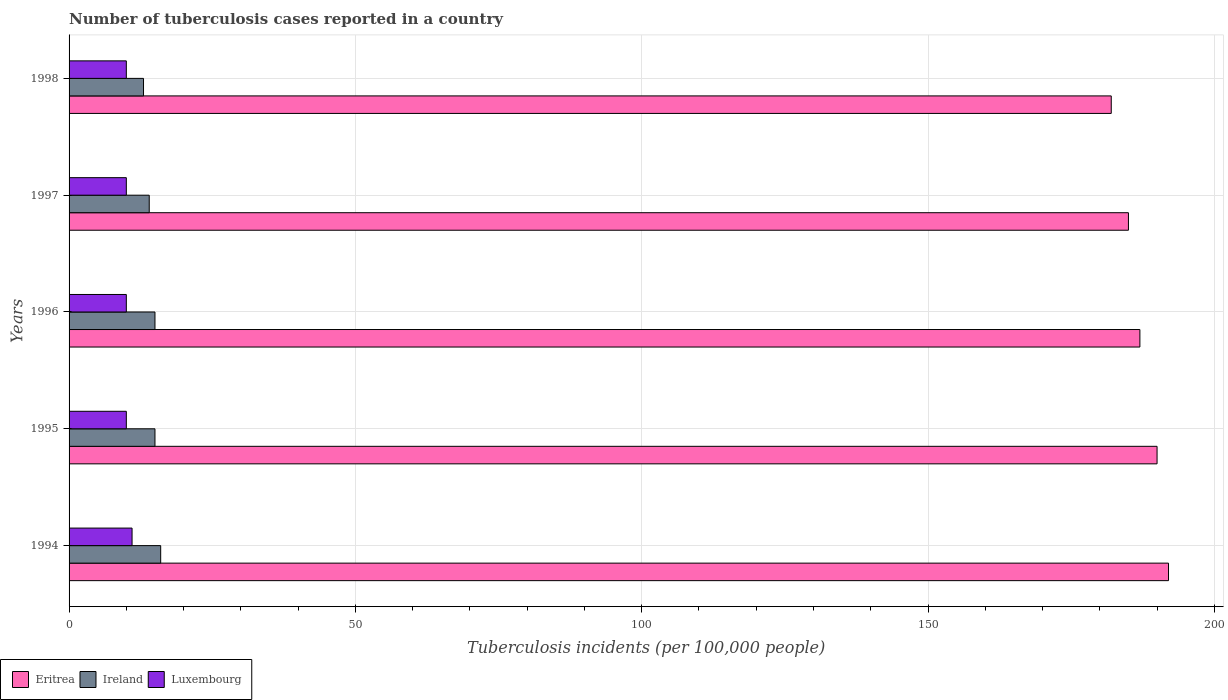How many groups of bars are there?
Make the answer very short. 5. How many bars are there on the 2nd tick from the bottom?
Provide a short and direct response. 3. Across all years, what is the maximum number of tuberculosis cases reported in in Ireland?
Your answer should be compact. 16. Across all years, what is the minimum number of tuberculosis cases reported in in Ireland?
Make the answer very short. 13. In which year was the number of tuberculosis cases reported in in Eritrea maximum?
Offer a terse response. 1994. In which year was the number of tuberculosis cases reported in in Eritrea minimum?
Your response must be concise. 1998. What is the difference between the number of tuberculosis cases reported in in Eritrea in 1995 and that in 1998?
Your response must be concise. 8. What is the difference between the number of tuberculosis cases reported in in Ireland in 1996 and the number of tuberculosis cases reported in in Luxembourg in 1995?
Keep it short and to the point. 5. In the year 1995, what is the difference between the number of tuberculosis cases reported in in Eritrea and number of tuberculosis cases reported in in Luxembourg?
Make the answer very short. 180. In how many years, is the number of tuberculosis cases reported in in Luxembourg greater than 140 ?
Your answer should be compact. 0. What is the ratio of the number of tuberculosis cases reported in in Ireland in 1994 to that in 1998?
Provide a short and direct response. 1.23. Is the difference between the number of tuberculosis cases reported in in Eritrea in 1994 and 1996 greater than the difference between the number of tuberculosis cases reported in in Luxembourg in 1994 and 1996?
Your answer should be very brief. Yes. What is the difference between the highest and the second highest number of tuberculosis cases reported in in Eritrea?
Give a very brief answer. 2. What is the difference between the highest and the lowest number of tuberculosis cases reported in in Eritrea?
Give a very brief answer. 10. What does the 3rd bar from the top in 1996 represents?
Your answer should be very brief. Eritrea. What does the 1st bar from the bottom in 1997 represents?
Give a very brief answer. Eritrea. Is it the case that in every year, the sum of the number of tuberculosis cases reported in in Eritrea and number of tuberculosis cases reported in in Luxembourg is greater than the number of tuberculosis cases reported in in Ireland?
Provide a succinct answer. Yes. How many bars are there?
Ensure brevity in your answer.  15. What is the difference between two consecutive major ticks on the X-axis?
Your answer should be compact. 50. Are the values on the major ticks of X-axis written in scientific E-notation?
Offer a terse response. No. Does the graph contain any zero values?
Offer a very short reply. No. How many legend labels are there?
Provide a succinct answer. 3. How are the legend labels stacked?
Provide a succinct answer. Horizontal. What is the title of the graph?
Your answer should be compact. Number of tuberculosis cases reported in a country. What is the label or title of the X-axis?
Give a very brief answer. Tuberculosis incidents (per 100,0 people). What is the label or title of the Y-axis?
Your response must be concise. Years. What is the Tuberculosis incidents (per 100,000 people) of Eritrea in 1994?
Provide a succinct answer. 192. What is the Tuberculosis incidents (per 100,000 people) of Luxembourg in 1994?
Ensure brevity in your answer.  11. What is the Tuberculosis incidents (per 100,000 people) in Eritrea in 1995?
Your response must be concise. 190. What is the Tuberculosis incidents (per 100,000 people) of Ireland in 1995?
Your answer should be compact. 15. What is the Tuberculosis incidents (per 100,000 people) of Eritrea in 1996?
Provide a short and direct response. 187. What is the Tuberculosis incidents (per 100,000 people) in Luxembourg in 1996?
Offer a terse response. 10. What is the Tuberculosis incidents (per 100,000 people) in Eritrea in 1997?
Offer a terse response. 185. What is the Tuberculosis incidents (per 100,000 people) of Ireland in 1997?
Provide a short and direct response. 14. What is the Tuberculosis incidents (per 100,000 people) in Eritrea in 1998?
Provide a succinct answer. 182. What is the Tuberculosis incidents (per 100,000 people) of Luxembourg in 1998?
Keep it short and to the point. 10. Across all years, what is the maximum Tuberculosis incidents (per 100,000 people) in Eritrea?
Make the answer very short. 192. Across all years, what is the maximum Tuberculosis incidents (per 100,000 people) in Luxembourg?
Make the answer very short. 11. Across all years, what is the minimum Tuberculosis incidents (per 100,000 people) in Eritrea?
Keep it short and to the point. 182. Across all years, what is the minimum Tuberculosis incidents (per 100,000 people) of Ireland?
Your response must be concise. 13. Across all years, what is the minimum Tuberculosis incidents (per 100,000 people) in Luxembourg?
Your response must be concise. 10. What is the total Tuberculosis incidents (per 100,000 people) in Eritrea in the graph?
Your answer should be compact. 936. What is the total Tuberculosis incidents (per 100,000 people) of Ireland in the graph?
Offer a terse response. 73. What is the difference between the Tuberculosis incidents (per 100,000 people) in Eritrea in 1994 and that in 1995?
Your answer should be compact. 2. What is the difference between the Tuberculosis incidents (per 100,000 people) in Luxembourg in 1994 and that in 1995?
Offer a terse response. 1. What is the difference between the Tuberculosis incidents (per 100,000 people) in Eritrea in 1994 and that in 1996?
Provide a short and direct response. 5. What is the difference between the Tuberculosis incidents (per 100,000 people) in Ireland in 1994 and that in 1996?
Provide a short and direct response. 1. What is the difference between the Tuberculosis incidents (per 100,000 people) of Eritrea in 1994 and that in 1997?
Ensure brevity in your answer.  7. What is the difference between the Tuberculosis incidents (per 100,000 people) of Luxembourg in 1994 and that in 1997?
Give a very brief answer. 1. What is the difference between the Tuberculosis incidents (per 100,000 people) of Eritrea in 1994 and that in 1998?
Your answer should be compact. 10. What is the difference between the Tuberculosis incidents (per 100,000 people) in Luxembourg in 1994 and that in 1998?
Your answer should be compact. 1. What is the difference between the Tuberculosis incidents (per 100,000 people) of Ireland in 1995 and that in 1996?
Offer a terse response. 0. What is the difference between the Tuberculosis incidents (per 100,000 people) of Luxembourg in 1995 and that in 1996?
Provide a succinct answer. 0. What is the difference between the Tuberculosis incidents (per 100,000 people) of Eritrea in 1995 and that in 1997?
Provide a short and direct response. 5. What is the difference between the Tuberculosis incidents (per 100,000 people) of Ireland in 1995 and that in 1997?
Your response must be concise. 1. What is the difference between the Tuberculosis incidents (per 100,000 people) of Luxembourg in 1995 and that in 1997?
Your response must be concise. 0. What is the difference between the Tuberculosis incidents (per 100,000 people) in Eritrea in 1996 and that in 1997?
Give a very brief answer. 2. What is the difference between the Tuberculosis incidents (per 100,000 people) of Ireland in 1996 and that in 1997?
Provide a succinct answer. 1. What is the difference between the Tuberculosis incidents (per 100,000 people) of Luxembourg in 1996 and that in 1997?
Your answer should be very brief. 0. What is the difference between the Tuberculosis incidents (per 100,000 people) of Ireland in 1996 and that in 1998?
Give a very brief answer. 2. What is the difference between the Tuberculosis incidents (per 100,000 people) in Luxembourg in 1996 and that in 1998?
Keep it short and to the point. 0. What is the difference between the Tuberculosis incidents (per 100,000 people) in Eritrea in 1997 and that in 1998?
Provide a short and direct response. 3. What is the difference between the Tuberculosis incidents (per 100,000 people) of Ireland in 1997 and that in 1998?
Your answer should be compact. 1. What is the difference between the Tuberculosis incidents (per 100,000 people) of Luxembourg in 1997 and that in 1998?
Provide a succinct answer. 0. What is the difference between the Tuberculosis incidents (per 100,000 people) of Eritrea in 1994 and the Tuberculosis incidents (per 100,000 people) of Ireland in 1995?
Your answer should be very brief. 177. What is the difference between the Tuberculosis incidents (per 100,000 people) of Eritrea in 1994 and the Tuberculosis incidents (per 100,000 people) of Luxembourg in 1995?
Ensure brevity in your answer.  182. What is the difference between the Tuberculosis incidents (per 100,000 people) in Eritrea in 1994 and the Tuberculosis incidents (per 100,000 people) in Ireland in 1996?
Offer a terse response. 177. What is the difference between the Tuberculosis incidents (per 100,000 people) in Eritrea in 1994 and the Tuberculosis incidents (per 100,000 people) in Luxembourg in 1996?
Ensure brevity in your answer.  182. What is the difference between the Tuberculosis incidents (per 100,000 people) in Eritrea in 1994 and the Tuberculosis incidents (per 100,000 people) in Ireland in 1997?
Your answer should be very brief. 178. What is the difference between the Tuberculosis incidents (per 100,000 people) of Eritrea in 1994 and the Tuberculosis incidents (per 100,000 people) of Luxembourg in 1997?
Offer a very short reply. 182. What is the difference between the Tuberculosis incidents (per 100,000 people) of Ireland in 1994 and the Tuberculosis incidents (per 100,000 people) of Luxembourg in 1997?
Your answer should be very brief. 6. What is the difference between the Tuberculosis incidents (per 100,000 people) in Eritrea in 1994 and the Tuberculosis incidents (per 100,000 people) in Ireland in 1998?
Give a very brief answer. 179. What is the difference between the Tuberculosis incidents (per 100,000 people) of Eritrea in 1994 and the Tuberculosis incidents (per 100,000 people) of Luxembourg in 1998?
Provide a succinct answer. 182. What is the difference between the Tuberculosis incidents (per 100,000 people) in Ireland in 1994 and the Tuberculosis incidents (per 100,000 people) in Luxembourg in 1998?
Provide a short and direct response. 6. What is the difference between the Tuberculosis incidents (per 100,000 people) of Eritrea in 1995 and the Tuberculosis incidents (per 100,000 people) of Ireland in 1996?
Your answer should be compact. 175. What is the difference between the Tuberculosis incidents (per 100,000 people) of Eritrea in 1995 and the Tuberculosis incidents (per 100,000 people) of Luxembourg in 1996?
Offer a terse response. 180. What is the difference between the Tuberculosis incidents (per 100,000 people) of Ireland in 1995 and the Tuberculosis incidents (per 100,000 people) of Luxembourg in 1996?
Your response must be concise. 5. What is the difference between the Tuberculosis incidents (per 100,000 people) of Eritrea in 1995 and the Tuberculosis incidents (per 100,000 people) of Ireland in 1997?
Offer a very short reply. 176. What is the difference between the Tuberculosis incidents (per 100,000 people) in Eritrea in 1995 and the Tuberculosis incidents (per 100,000 people) in Luxembourg in 1997?
Offer a very short reply. 180. What is the difference between the Tuberculosis incidents (per 100,000 people) in Ireland in 1995 and the Tuberculosis incidents (per 100,000 people) in Luxembourg in 1997?
Provide a short and direct response. 5. What is the difference between the Tuberculosis incidents (per 100,000 people) of Eritrea in 1995 and the Tuberculosis incidents (per 100,000 people) of Ireland in 1998?
Provide a succinct answer. 177. What is the difference between the Tuberculosis incidents (per 100,000 people) in Eritrea in 1995 and the Tuberculosis incidents (per 100,000 people) in Luxembourg in 1998?
Your answer should be very brief. 180. What is the difference between the Tuberculosis incidents (per 100,000 people) of Eritrea in 1996 and the Tuberculosis incidents (per 100,000 people) of Ireland in 1997?
Offer a terse response. 173. What is the difference between the Tuberculosis incidents (per 100,000 people) in Eritrea in 1996 and the Tuberculosis incidents (per 100,000 people) in Luxembourg in 1997?
Your answer should be compact. 177. What is the difference between the Tuberculosis incidents (per 100,000 people) in Eritrea in 1996 and the Tuberculosis incidents (per 100,000 people) in Ireland in 1998?
Your answer should be very brief. 174. What is the difference between the Tuberculosis incidents (per 100,000 people) in Eritrea in 1996 and the Tuberculosis incidents (per 100,000 people) in Luxembourg in 1998?
Your response must be concise. 177. What is the difference between the Tuberculosis incidents (per 100,000 people) in Ireland in 1996 and the Tuberculosis incidents (per 100,000 people) in Luxembourg in 1998?
Make the answer very short. 5. What is the difference between the Tuberculosis incidents (per 100,000 people) of Eritrea in 1997 and the Tuberculosis incidents (per 100,000 people) of Ireland in 1998?
Provide a succinct answer. 172. What is the difference between the Tuberculosis incidents (per 100,000 people) in Eritrea in 1997 and the Tuberculosis incidents (per 100,000 people) in Luxembourg in 1998?
Keep it short and to the point. 175. What is the difference between the Tuberculosis incidents (per 100,000 people) of Ireland in 1997 and the Tuberculosis incidents (per 100,000 people) of Luxembourg in 1998?
Your response must be concise. 4. What is the average Tuberculosis incidents (per 100,000 people) of Eritrea per year?
Give a very brief answer. 187.2. In the year 1994, what is the difference between the Tuberculosis incidents (per 100,000 people) of Eritrea and Tuberculosis incidents (per 100,000 people) of Ireland?
Make the answer very short. 176. In the year 1994, what is the difference between the Tuberculosis incidents (per 100,000 people) in Eritrea and Tuberculosis incidents (per 100,000 people) in Luxembourg?
Your answer should be compact. 181. In the year 1995, what is the difference between the Tuberculosis incidents (per 100,000 people) of Eritrea and Tuberculosis incidents (per 100,000 people) of Ireland?
Offer a terse response. 175. In the year 1995, what is the difference between the Tuberculosis incidents (per 100,000 people) in Eritrea and Tuberculosis incidents (per 100,000 people) in Luxembourg?
Give a very brief answer. 180. In the year 1995, what is the difference between the Tuberculosis incidents (per 100,000 people) in Ireland and Tuberculosis incidents (per 100,000 people) in Luxembourg?
Your answer should be very brief. 5. In the year 1996, what is the difference between the Tuberculosis incidents (per 100,000 people) of Eritrea and Tuberculosis incidents (per 100,000 people) of Ireland?
Make the answer very short. 172. In the year 1996, what is the difference between the Tuberculosis incidents (per 100,000 people) of Eritrea and Tuberculosis incidents (per 100,000 people) of Luxembourg?
Keep it short and to the point. 177. In the year 1997, what is the difference between the Tuberculosis incidents (per 100,000 people) of Eritrea and Tuberculosis incidents (per 100,000 people) of Ireland?
Give a very brief answer. 171. In the year 1997, what is the difference between the Tuberculosis incidents (per 100,000 people) in Eritrea and Tuberculosis incidents (per 100,000 people) in Luxembourg?
Your answer should be compact. 175. In the year 1997, what is the difference between the Tuberculosis incidents (per 100,000 people) of Ireland and Tuberculosis incidents (per 100,000 people) of Luxembourg?
Your answer should be very brief. 4. In the year 1998, what is the difference between the Tuberculosis incidents (per 100,000 people) of Eritrea and Tuberculosis incidents (per 100,000 people) of Ireland?
Your answer should be compact. 169. In the year 1998, what is the difference between the Tuberculosis incidents (per 100,000 people) of Eritrea and Tuberculosis incidents (per 100,000 people) of Luxembourg?
Make the answer very short. 172. What is the ratio of the Tuberculosis incidents (per 100,000 people) of Eritrea in 1994 to that in 1995?
Give a very brief answer. 1.01. What is the ratio of the Tuberculosis incidents (per 100,000 people) in Ireland in 1994 to that in 1995?
Offer a terse response. 1.07. What is the ratio of the Tuberculosis incidents (per 100,000 people) in Eritrea in 1994 to that in 1996?
Ensure brevity in your answer.  1.03. What is the ratio of the Tuberculosis incidents (per 100,000 people) of Ireland in 1994 to that in 1996?
Your answer should be compact. 1.07. What is the ratio of the Tuberculosis incidents (per 100,000 people) in Luxembourg in 1994 to that in 1996?
Ensure brevity in your answer.  1.1. What is the ratio of the Tuberculosis incidents (per 100,000 people) in Eritrea in 1994 to that in 1997?
Your answer should be very brief. 1.04. What is the ratio of the Tuberculosis incidents (per 100,000 people) of Luxembourg in 1994 to that in 1997?
Your answer should be compact. 1.1. What is the ratio of the Tuberculosis incidents (per 100,000 people) of Eritrea in 1994 to that in 1998?
Your response must be concise. 1.05. What is the ratio of the Tuberculosis incidents (per 100,000 people) of Ireland in 1994 to that in 1998?
Your answer should be very brief. 1.23. What is the ratio of the Tuberculosis incidents (per 100,000 people) of Eritrea in 1995 to that in 1996?
Give a very brief answer. 1.02. What is the ratio of the Tuberculosis incidents (per 100,000 people) of Ireland in 1995 to that in 1996?
Your response must be concise. 1. What is the ratio of the Tuberculosis incidents (per 100,000 people) of Ireland in 1995 to that in 1997?
Your response must be concise. 1.07. What is the ratio of the Tuberculosis incidents (per 100,000 people) of Luxembourg in 1995 to that in 1997?
Your answer should be very brief. 1. What is the ratio of the Tuberculosis incidents (per 100,000 people) of Eritrea in 1995 to that in 1998?
Your response must be concise. 1.04. What is the ratio of the Tuberculosis incidents (per 100,000 people) in Ireland in 1995 to that in 1998?
Your answer should be compact. 1.15. What is the ratio of the Tuberculosis incidents (per 100,000 people) in Eritrea in 1996 to that in 1997?
Your answer should be compact. 1.01. What is the ratio of the Tuberculosis incidents (per 100,000 people) in Ireland in 1996 to that in 1997?
Make the answer very short. 1.07. What is the ratio of the Tuberculosis incidents (per 100,000 people) in Eritrea in 1996 to that in 1998?
Make the answer very short. 1.03. What is the ratio of the Tuberculosis incidents (per 100,000 people) of Ireland in 1996 to that in 1998?
Ensure brevity in your answer.  1.15. What is the ratio of the Tuberculosis incidents (per 100,000 people) in Luxembourg in 1996 to that in 1998?
Your answer should be compact. 1. What is the ratio of the Tuberculosis incidents (per 100,000 people) of Eritrea in 1997 to that in 1998?
Provide a short and direct response. 1.02. What is the ratio of the Tuberculosis incidents (per 100,000 people) in Ireland in 1997 to that in 1998?
Make the answer very short. 1.08. What is the ratio of the Tuberculosis incidents (per 100,000 people) of Luxembourg in 1997 to that in 1998?
Keep it short and to the point. 1. What is the difference between the highest and the second highest Tuberculosis incidents (per 100,000 people) in Eritrea?
Keep it short and to the point. 2. What is the difference between the highest and the second highest Tuberculosis incidents (per 100,000 people) in Ireland?
Ensure brevity in your answer.  1. What is the difference between the highest and the second highest Tuberculosis incidents (per 100,000 people) of Luxembourg?
Offer a terse response. 1. What is the difference between the highest and the lowest Tuberculosis incidents (per 100,000 people) in Eritrea?
Keep it short and to the point. 10. 